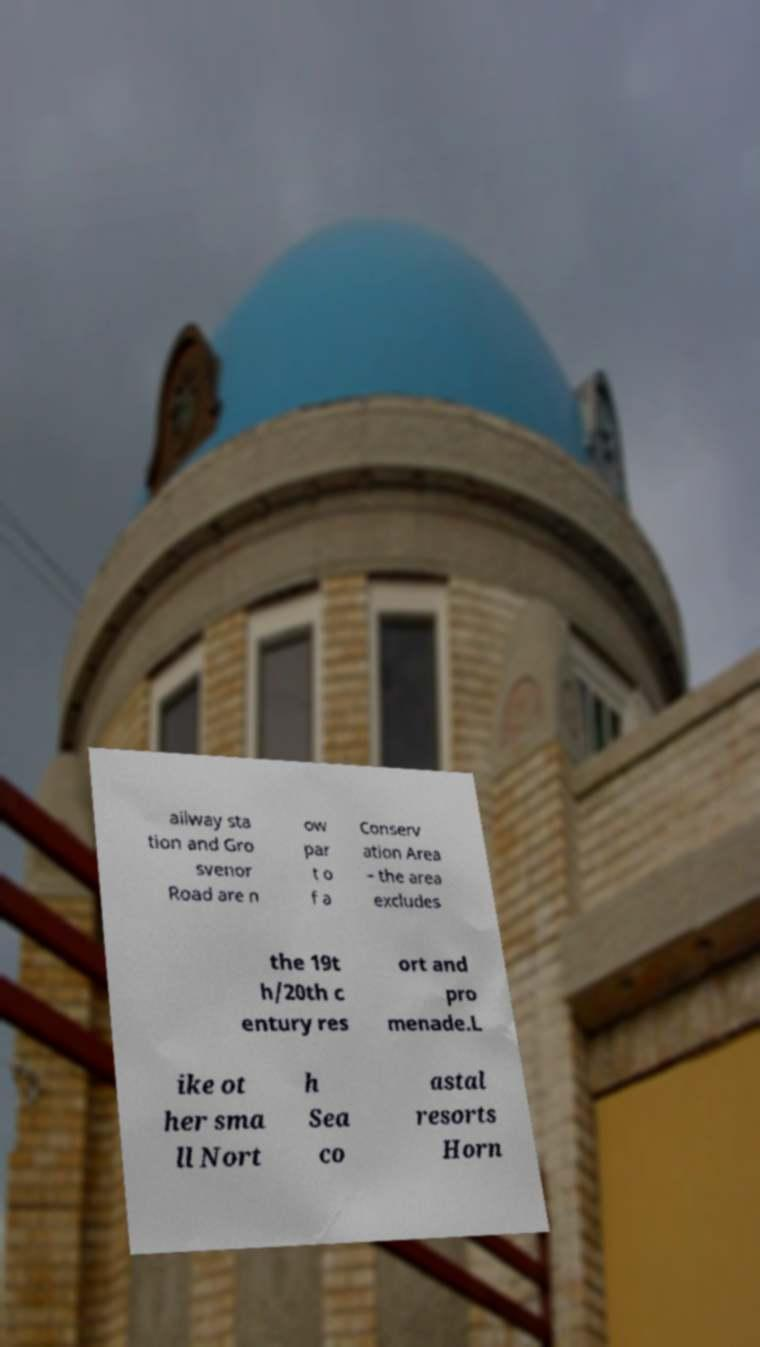Please identify and transcribe the text found in this image. ailway sta tion and Gro svenor Road are n ow par t o f a Conserv ation Area – the area excludes the 19t h/20th c entury res ort and pro menade.L ike ot her sma ll Nort h Sea co astal resorts Horn 